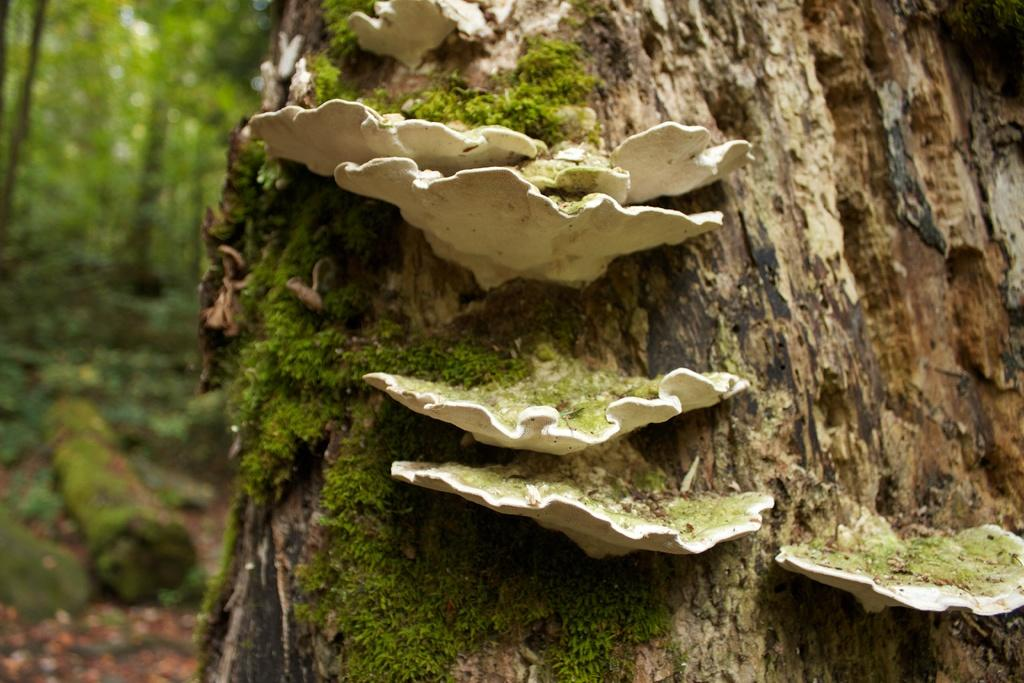What is located in the center of the image? There is a tree and mushrooms in the center of the image. What color are the mushrooms? The mushrooms are white in color. What can be seen in the background of the image? There are trees and grass visible in the background of the image. How many cows are visible in the image? There are no cows present in the image. What type of fuel is being used by the mushrooms in the image? There is no fuel being used by the mushrooms in the image; they are simply growing in the forest. 